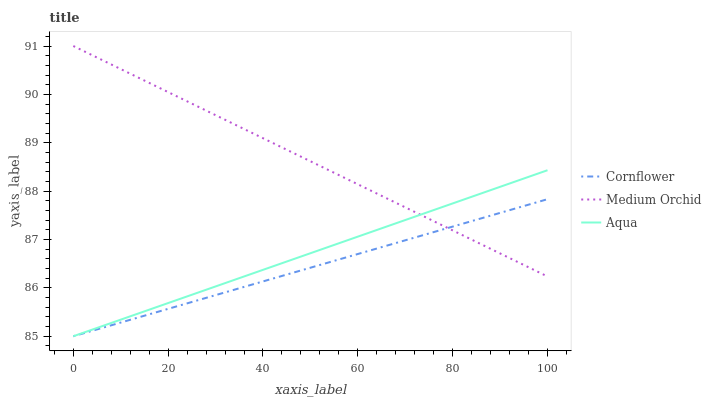Does Cornflower have the minimum area under the curve?
Answer yes or no. Yes. Does Medium Orchid have the maximum area under the curve?
Answer yes or no. Yes. Does Aqua have the minimum area under the curve?
Answer yes or no. No. Does Aqua have the maximum area under the curve?
Answer yes or no. No. Is Medium Orchid the smoothest?
Answer yes or no. Yes. Is Cornflower the roughest?
Answer yes or no. Yes. Is Aqua the smoothest?
Answer yes or no. No. Is Aqua the roughest?
Answer yes or no. No. Does Cornflower have the lowest value?
Answer yes or no. Yes. Does Medium Orchid have the lowest value?
Answer yes or no. No. Does Medium Orchid have the highest value?
Answer yes or no. Yes. Does Aqua have the highest value?
Answer yes or no. No. Does Cornflower intersect Aqua?
Answer yes or no. Yes. Is Cornflower less than Aqua?
Answer yes or no. No. Is Cornflower greater than Aqua?
Answer yes or no. No. 